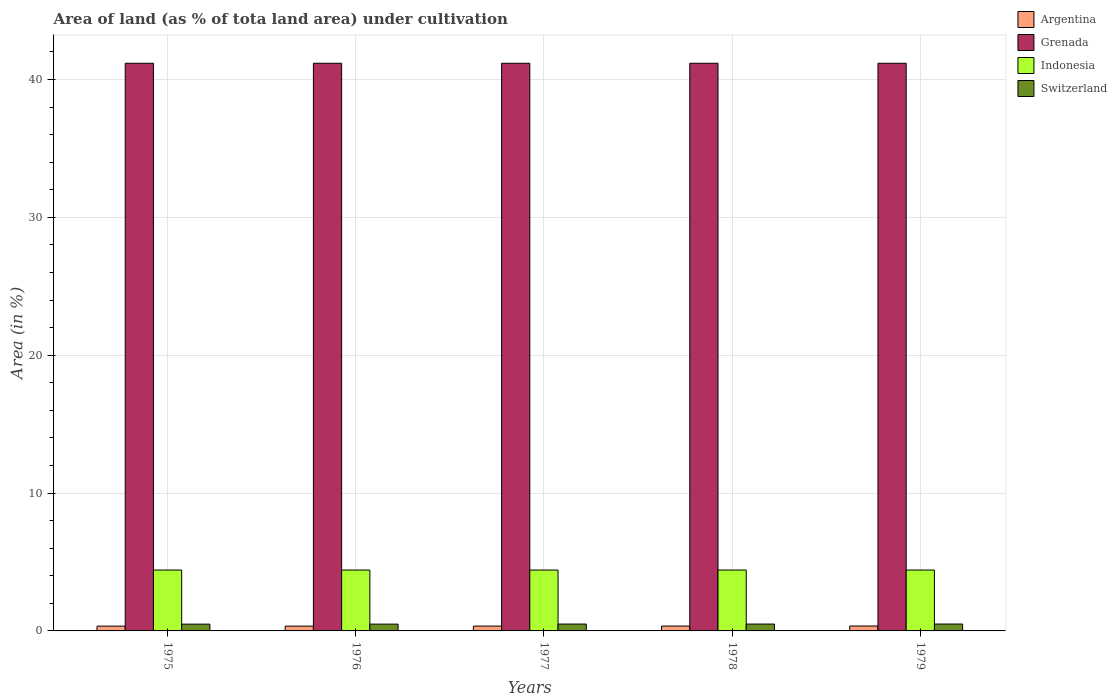What is the label of the 2nd group of bars from the left?
Provide a short and direct response. 1976. What is the percentage of land under cultivation in Switzerland in 1976?
Make the answer very short. 0.49. Across all years, what is the maximum percentage of land under cultivation in Grenada?
Offer a terse response. 41.18. Across all years, what is the minimum percentage of land under cultivation in Grenada?
Your answer should be very brief. 41.18. In which year was the percentage of land under cultivation in Indonesia maximum?
Offer a terse response. 1975. In which year was the percentage of land under cultivation in Grenada minimum?
Your answer should be very brief. 1975. What is the total percentage of land under cultivation in Argentina in the graph?
Offer a terse response. 1.76. What is the difference between the percentage of land under cultivation in Switzerland in 1976 and that in 1979?
Your answer should be compact. -0.01. What is the difference between the percentage of land under cultivation in Grenada in 1977 and the percentage of land under cultivation in Indonesia in 1979?
Ensure brevity in your answer.  36.76. What is the average percentage of land under cultivation in Switzerland per year?
Keep it short and to the point. 0.5. In the year 1977, what is the difference between the percentage of land under cultivation in Switzerland and percentage of land under cultivation in Grenada?
Make the answer very short. -40.68. What is the ratio of the percentage of land under cultivation in Argentina in 1975 to that in 1978?
Offer a very short reply. 0.98. Is the percentage of land under cultivation in Switzerland in 1977 less than that in 1979?
Provide a short and direct response. Yes. What is the difference between the highest and the second highest percentage of land under cultivation in Indonesia?
Provide a short and direct response. 0. In how many years, is the percentage of land under cultivation in Grenada greater than the average percentage of land under cultivation in Grenada taken over all years?
Offer a terse response. 0. Is the sum of the percentage of land under cultivation in Argentina in 1975 and 1978 greater than the maximum percentage of land under cultivation in Indonesia across all years?
Your response must be concise. No. Is it the case that in every year, the sum of the percentage of land under cultivation in Argentina and percentage of land under cultivation in Grenada is greater than the sum of percentage of land under cultivation in Indonesia and percentage of land under cultivation in Switzerland?
Your response must be concise. No. What does the 4th bar from the left in 1975 represents?
Your answer should be compact. Switzerland. How many bars are there?
Ensure brevity in your answer.  20. What is the difference between two consecutive major ticks on the Y-axis?
Your answer should be very brief. 10. Are the values on the major ticks of Y-axis written in scientific E-notation?
Keep it short and to the point. No. Where does the legend appear in the graph?
Make the answer very short. Top right. How many legend labels are there?
Offer a terse response. 4. How are the legend labels stacked?
Your answer should be compact. Vertical. What is the title of the graph?
Give a very brief answer. Area of land (as % of tota land area) under cultivation. Does "Dominican Republic" appear as one of the legend labels in the graph?
Ensure brevity in your answer.  No. What is the label or title of the X-axis?
Provide a short and direct response. Years. What is the label or title of the Y-axis?
Offer a terse response. Area (in %). What is the Area (in %) of Argentina in 1975?
Ensure brevity in your answer.  0.35. What is the Area (in %) of Grenada in 1975?
Keep it short and to the point. 41.18. What is the Area (in %) in Indonesia in 1975?
Your answer should be compact. 4.42. What is the Area (in %) of Switzerland in 1975?
Your response must be concise. 0.49. What is the Area (in %) of Argentina in 1976?
Provide a succinct answer. 0.35. What is the Area (in %) in Grenada in 1976?
Keep it short and to the point. 41.18. What is the Area (in %) in Indonesia in 1976?
Your answer should be very brief. 4.42. What is the Area (in %) of Switzerland in 1976?
Give a very brief answer. 0.49. What is the Area (in %) in Argentina in 1977?
Your answer should be compact. 0.35. What is the Area (in %) in Grenada in 1977?
Make the answer very short. 41.18. What is the Area (in %) of Indonesia in 1977?
Make the answer very short. 4.42. What is the Area (in %) of Switzerland in 1977?
Make the answer very short. 0.5. What is the Area (in %) of Argentina in 1978?
Provide a short and direct response. 0.35. What is the Area (in %) in Grenada in 1978?
Your response must be concise. 41.18. What is the Area (in %) in Indonesia in 1978?
Your answer should be very brief. 4.42. What is the Area (in %) in Switzerland in 1978?
Make the answer very short. 0.5. What is the Area (in %) of Argentina in 1979?
Your answer should be compact. 0.36. What is the Area (in %) of Grenada in 1979?
Provide a succinct answer. 41.18. What is the Area (in %) in Indonesia in 1979?
Ensure brevity in your answer.  4.42. What is the Area (in %) of Switzerland in 1979?
Provide a succinct answer. 0.5. Across all years, what is the maximum Area (in %) of Argentina?
Your answer should be very brief. 0.36. Across all years, what is the maximum Area (in %) of Grenada?
Make the answer very short. 41.18. Across all years, what is the maximum Area (in %) in Indonesia?
Your answer should be compact. 4.42. Across all years, what is the maximum Area (in %) in Switzerland?
Offer a very short reply. 0.5. Across all years, what is the minimum Area (in %) in Argentina?
Offer a very short reply. 0.35. Across all years, what is the minimum Area (in %) in Grenada?
Give a very brief answer. 41.18. Across all years, what is the minimum Area (in %) of Indonesia?
Provide a succinct answer. 4.42. Across all years, what is the minimum Area (in %) of Switzerland?
Provide a short and direct response. 0.49. What is the total Area (in %) in Argentina in the graph?
Keep it short and to the point. 1.76. What is the total Area (in %) of Grenada in the graph?
Your answer should be very brief. 205.88. What is the total Area (in %) in Indonesia in the graph?
Your answer should be very brief. 22.08. What is the total Area (in %) of Switzerland in the graph?
Make the answer very short. 2.48. What is the difference between the Area (in %) in Argentina in 1975 and that in 1976?
Your answer should be very brief. -0. What is the difference between the Area (in %) of Grenada in 1975 and that in 1976?
Offer a very short reply. 0. What is the difference between the Area (in %) of Indonesia in 1975 and that in 1976?
Provide a short and direct response. 0. What is the difference between the Area (in %) in Switzerland in 1975 and that in 1976?
Give a very brief answer. -0. What is the difference between the Area (in %) in Argentina in 1975 and that in 1977?
Make the answer very short. -0. What is the difference between the Area (in %) in Indonesia in 1975 and that in 1977?
Ensure brevity in your answer.  0. What is the difference between the Area (in %) of Switzerland in 1975 and that in 1977?
Your answer should be compact. -0.01. What is the difference between the Area (in %) in Argentina in 1975 and that in 1978?
Give a very brief answer. -0.01. What is the difference between the Area (in %) in Switzerland in 1975 and that in 1978?
Your answer should be compact. -0.01. What is the difference between the Area (in %) of Argentina in 1975 and that in 1979?
Make the answer very short. -0.01. What is the difference between the Area (in %) of Switzerland in 1975 and that in 1979?
Your response must be concise. -0.01. What is the difference between the Area (in %) of Argentina in 1976 and that in 1977?
Your response must be concise. -0. What is the difference between the Area (in %) of Indonesia in 1976 and that in 1977?
Keep it short and to the point. 0. What is the difference between the Area (in %) in Switzerland in 1976 and that in 1977?
Make the answer very short. -0.01. What is the difference between the Area (in %) of Argentina in 1976 and that in 1978?
Ensure brevity in your answer.  -0. What is the difference between the Area (in %) of Grenada in 1976 and that in 1978?
Provide a short and direct response. 0. What is the difference between the Area (in %) in Switzerland in 1976 and that in 1978?
Ensure brevity in your answer.  -0.01. What is the difference between the Area (in %) of Argentina in 1976 and that in 1979?
Offer a terse response. -0.01. What is the difference between the Area (in %) in Grenada in 1976 and that in 1979?
Your answer should be very brief. 0. What is the difference between the Area (in %) in Indonesia in 1976 and that in 1979?
Ensure brevity in your answer.  0. What is the difference between the Area (in %) in Switzerland in 1976 and that in 1979?
Make the answer very short. -0.01. What is the difference between the Area (in %) of Argentina in 1977 and that in 1978?
Offer a very short reply. -0. What is the difference between the Area (in %) in Switzerland in 1977 and that in 1978?
Make the answer very short. 0. What is the difference between the Area (in %) of Argentina in 1977 and that in 1979?
Keep it short and to the point. -0. What is the difference between the Area (in %) in Grenada in 1977 and that in 1979?
Give a very brief answer. 0. What is the difference between the Area (in %) in Switzerland in 1977 and that in 1979?
Provide a short and direct response. -0. What is the difference between the Area (in %) in Argentina in 1978 and that in 1979?
Offer a very short reply. -0. What is the difference between the Area (in %) in Indonesia in 1978 and that in 1979?
Your answer should be very brief. 0. What is the difference between the Area (in %) in Switzerland in 1978 and that in 1979?
Ensure brevity in your answer.  -0. What is the difference between the Area (in %) in Argentina in 1975 and the Area (in %) in Grenada in 1976?
Offer a very short reply. -40.83. What is the difference between the Area (in %) in Argentina in 1975 and the Area (in %) in Indonesia in 1976?
Your answer should be very brief. -4.07. What is the difference between the Area (in %) of Argentina in 1975 and the Area (in %) of Switzerland in 1976?
Provide a short and direct response. -0.15. What is the difference between the Area (in %) in Grenada in 1975 and the Area (in %) in Indonesia in 1976?
Give a very brief answer. 36.76. What is the difference between the Area (in %) in Grenada in 1975 and the Area (in %) in Switzerland in 1976?
Your answer should be very brief. 40.68. What is the difference between the Area (in %) of Indonesia in 1975 and the Area (in %) of Switzerland in 1976?
Give a very brief answer. 3.92. What is the difference between the Area (in %) of Argentina in 1975 and the Area (in %) of Grenada in 1977?
Your response must be concise. -40.83. What is the difference between the Area (in %) in Argentina in 1975 and the Area (in %) in Indonesia in 1977?
Your answer should be very brief. -4.07. What is the difference between the Area (in %) of Argentina in 1975 and the Area (in %) of Switzerland in 1977?
Provide a succinct answer. -0.15. What is the difference between the Area (in %) in Grenada in 1975 and the Area (in %) in Indonesia in 1977?
Your answer should be compact. 36.76. What is the difference between the Area (in %) in Grenada in 1975 and the Area (in %) in Switzerland in 1977?
Your answer should be very brief. 40.68. What is the difference between the Area (in %) of Indonesia in 1975 and the Area (in %) of Switzerland in 1977?
Keep it short and to the point. 3.92. What is the difference between the Area (in %) of Argentina in 1975 and the Area (in %) of Grenada in 1978?
Your answer should be very brief. -40.83. What is the difference between the Area (in %) in Argentina in 1975 and the Area (in %) in Indonesia in 1978?
Provide a short and direct response. -4.07. What is the difference between the Area (in %) in Argentina in 1975 and the Area (in %) in Switzerland in 1978?
Your answer should be very brief. -0.15. What is the difference between the Area (in %) in Grenada in 1975 and the Area (in %) in Indonesia in 1978?
Provide a short and direct response. 36.76. What is the difference between the Area (in %) of Grenada in 1975 and the Area (in %) of Switzerland in 1978?
Keep it short and to the point. 40.68. What is the difference between the Area (in %) of Indonesia in 1975 and the Area (in %) of Switzerland in 1978?
Give a very brief answer. 3.92. What is the difference between the Area (in %) in Argentina in 1975 and the Area (in %) in Grenada in 1979?
Provide a succinct answer. -40.83. What is the difference between the Area (in %) in Argentina in 1975 and the Area (in %) in Indonesia in 1979?
Keep it short and to the point. -4.07. What is the difference between the Area (in %) of Argentina in 1975 and the Area (in %) of Switzerland in 1979?
Give a very brief answer. -0.15. What is the difference between the Area (in %) in Grenada in 1975 and the Area (in %) in Indonesia in 1979?
Offer a terse response. 36.76. What is the difference between the Area (in %) in Grenada in 1975 and the Area (in %) in Switzerland in 1979?
Provide a short and direct response. 40.68. What is the difference between the Area (in %) of Indonesia in 1975 and the Area (in %) of Switzerland in 1979?
Offer a terse response. 3.92. What is the difference between the Area (in %) in Argentina in 1976 and the Area (in %) in Grenada in 1977?
Provide a succinct answer. -40.83. What is the difference between the Area (in %) in Argentina in 1976 and the Area (in %) in Indonesia in 1977?
Make the answer very short. -4.07. What is the difference between the Area (in %) of Argentina in 1976 and the Area (in %) of Switzerland in 1977?
Your response must be concise. -0.15. What is the difference between the Area (in %) in Grenada in 1976 and the Area (in %) in Indonesia in 1977?
Your response must be concise. 36.76. What is the difference between the Area (in %) in Grenada in 1976 and the Area (in %) in Switzerland in 1977?
Offer a terse response. 40.68. What is the difference between the Area (in %) of Indonesia in 1976 and the Area (in %) of Switzerland in 1977?
Your answer should be compact. 3.92. What is the difference between the Area (in %) in Argentina in 1976 and the Area (in %) in Grenada in 1978?
Provide a succinct answer. -40.83. What is the difference between the Area (in %) of Argentina in 1976 and the Area (in %) of Indonesia in 1978?
Provide a short and direct response. -4.07. What is the difference between the Area (in %) in Argentina in 1976 and the Area (in %) in Switzerland in 1978?
Ensure brevity in your answer.  -0.15. What is the difference between the Area (in %) in Grenada in 1976 and the Area (in %) in Indonesia in 1978?
Your response must be concise. 36.76. What is the difference between the Area (in %) of Grenada in 1976 and the Area (in %) of Switzerland in 1978?
Your answer should be compact. 40.68. What is the difference between the Area (in %) of Indonesia in 1976 and the Area (in %) of Switzerland in 1978?
Make the answer very short. 3.92. What is the difference between the Area (in %) of Argentina in 1976 and the Area (in %) of Grenada in 1979?
Give a very brief answer. -40.83. What is the difference between the Area (in %) of Argentina in 1976 and the Area (in %) of Indonesia in 1979?
Make the answer very short. -4.07. What is the difference between the Area (in %) of Argentina in 1976 and the Area (in %) of Switzerland in 1979?
Offer a terse response. -0.15. What is the difference between the Area (in %) of Grenada in 1976 and the Area (in %) of Indonesia in 1979?
Your answer should be compact. 36.76. What is the difference between the Area (in %) of Grenada in 1976 and the Area (in %) of Switzerland in 1979?
Your answer should be very brief. 40.68. What is the difference between the Area (in %) of Indonesia in 1976 and the Area (in %) of Switzerland in 1979?
Ensure brevity in your answer.  3.92. What is the difference between the Area (in %) in Argentina in 1977 and the Area (in %) in Grenada in 1978?
Your answer should be compact. -40.82. What is the difference between the Area (in %) of Argentina in 1977 and the Area (in %) of Indonesia in 1978?
Provide a short and direct response. -4.06. What is the difference between the Area (in %) in Argentina in 1977 and the Area (in %) in Switzerland in 1978?
Your answer should be compact. -0.15. What is the difference between the Area (in %) in Grenada in 1977 and the Area (in %) in Indonesia in 1978?
Provide a short and direct response. 36.76. What is the difference between the Area (in %) in Grenada in 1977 and the Area (in %) in Switzerland in 1978?
Offer a terse response. 40.68. What is the difference between the Area (in %) in Indonesia in 1977 and the Area (in %) in Switzerland in 1978?
Make the answer very short. 3.92. What is the difference between the Area (in %) in Argentina in 1977 and the Area (in %) in Grenada in 1979?
Offer a very short reply. -40.82. What is the difference between the Area (in %) in Argentina in 1977 and the Area (in %) in Indonesia in 1979?
Ensure brevity in your answer.  -4.06. What is the difference between the Area (in %) in Argentina in 1977 and the Area (in %) in Switzerland in 1979?
Make the answer very short. -0.15. What is the difference between the Area (in %) of Grenada in 1977 and the Area (in %) of Indonesia in 1979?
Keep it short and to the point. 36.76. What is the difference between the Area (in %) of Grenada in 1977 and the Area (in %) of Switzerland in 1979?
Provide a succinct answer. 40.68. What is the difference between the Area (in %) of Indonesia in 1977 and the Area (in %) of Switzerland in 1979?
Your response must be concise. 3.92. What is the difference between the Area (in %) of Argentina in 1978 and the Area (in %) of Grenada in 1979?
Provide a succinct answer. -40.82. What is the difference between the Area (in %) of Argentina in 1978 and the Area (in %) of Indonesia in 1979?
Offer a very short reply. -4.06. What is the difference between the Area (in %) in Argentina in 1978 and the Area (in %) in Switzerland in 1979?
Provide a short and direct response. -0.15. What is the difference between the Area (in %) of Grenada in 1978 and the Area (in %) of Indonesia in 1979?
Your answer should be compact. 36.76. What is the difference between the Area (in %) in Grenada in 1978 and the Area (in %) in Switzerland in 1979?
Ensure brevity in your answer.  40.68. What is the difference between the Area (in %) of Indonesia in 1978 and the Area (in %) of Switzerland in 1979?
Your answer should be compact. 3.92. What is the average Area (in %) of Argentina per year?
Make the answer very short. 0.35. What is the average Area (in %) of Grenada per year?
Ensure brevity in your answer.  41.18. What is the average Area (in %) of Indonesia per year?
Give a very brief answer. 4.42. What is the average Area (in %) in Switzerland per year?
Offer a very short reply. 0.5. In the year 1975, what is the difference between the Area (in %) in Argentina and Area (in %) in Grenada?
Your response must be concise. -40.83. In the year 1975, what is the difference between the Area (in %) of Argentina and Area (in %) of Indonesia?
Ensure brevity in your answer.  -4.07. In the year 1975, what is the difference between the Area (in %) of Argentina and Area (in %) of Switzerland?
Your answer should be very brief. -0.14. In the year 1975, what is the difference between the Area (in %) in Grenada and Area (in %) in Indonesia?
Keep it short and to the point. 36.76. In the year 1975, what is the difference between the Area (in %) of Grenada and Area (in %) of Switzerland?
Give a very brief answer. 40.69. In the year 1975, what is the difference between the Area (in %) of Indonesia and Area (in %) of Switzerland?
Offer a terse response. 3.93. In the year 1976, what is the difference between the Area (in %) in Argentina and Area (in %) in Grenada?
Provide a short and direct response. -40.83. In the year 1976, what is the difference between the Area (in %) in Argentina and Area (in %) in Indonesia?
Offer a very short reply. -4.07. In the year 1976, what is the difference between the Area (in %) of Argentina and Area (in %) of Switzerland?
Provide a succinct answer. -0.14. In the year 1976, what is the difference between the Area (in %) of Grenada and Area (in %) of Indonesia?
Provide a succinct answer. 36.76. In the year 1976, what is the difference between the Area (in %) of Grenada and Area (in %) of Switzerland?
Your answer should be very brief. 40.68. In the year 1976, what is the difference between the Area (in %) in Indonesia and Area (in %) in Switzerland?
Offer a terse response. 3.92. In the year 1977, what is the difference between the Area (in %) in Argentina and Area (in %) in Grenada?
Make the answer very short. -40.82. In the year 1977, what is the difference between the Area (in %) of Argentina and Area (in %) of Indonesia?
Offer a terse response. -4.06. In the year 1977, what is the difference between the Area (in %) in Argentina and Area (in %) in Switzerland?
Your response must be concise. -0.15. In the year 1977, what is the difference between the Area (in %) of Grenada and Area (in %) of Indonesia?
Your answer should be compact. 36.76. In the year 1977, what is the difference between the Area (in %) in Grenada and Area (in %) in Switzerland?
Your answer should be very brief. 40.68. In the year 1977, what is the difference between the Area (in %) of Indonesia and Area (in %) of Switzerland?
Provide a short and direct response. 3.92. In the year 1978, what is the difference between the Area (in %) of Argentina and Area (in %) of Grenada?
Provide a succinct answer. -40.82. In the year 1978, what is the difference between the Area (in %) in Argentina and Area (in %) in Indonesia?
Keep it short and to the point. -4.06. In the year 1978, what is the difference between the Area (in %) of Argentina and Area (in %) of Switzerland?
Provide a succinct answer. -0.14. In the year 1978, what is the difference between the Area (in %) of Grenada and Area (in %) of Indonesia?
Give a very brief answer. 36.76. In the year 1978, what is the difference between the Area (in %) of Grenada and Area (in %) of Switzerland?
Provide a short and direct response. 40.68. In the year 1978, what is the difference between the Area (in %) in Indonesia and Area (in %) in Switzerland?
Your answer should be compact. 3.92. In the year 1979, what is the difference between the Area (in %) in Argentina and Area (in %) in Grenada?
Offer a terse response. -40.82. In the year 1979, what is the difference between the Area (in %) of Argentina and Area (in %) of Indonesia?
Ensure brevity in your answer.  -4.06. In the year 1979, what is the difference between the Area (in %) of Argentina and Area (in %) of Switzerland?
Your answer should be very brief. -0.14. In the year 1979, what is the difference between the Area (in %) in Grenada and Area (in %) in Indonesia?
Your response must be concise. 36.76. In the year 1979, what is the difference between the Area (in %) of Grenada and Area (in %) of Switzerland?
Offer a terse response. 40.68. In the year 1979, what is the difference between the Area (in %) in Indonesia and Area (in %) in Switzerland?
Your answer should be very brief. 3.92. What is the ratio of the Area (in %) of Argentina in 1975 to that in 1976?
Offer a very short reply. 0.99. What is the ratio of the Area (in %) in Indonesia in 1975 to that in 1976?
Provide a short and direct response. 1. What is the ratio of the Area (in %) of Switzerland in 1975 to that in 1976?
Your answer should be very brief. 0.99. What is the ratio of the Area (in %) of Grenada in 1975 to that in 1977?
Make the answer very short. 1. What is the ratio of the Area (in %) in Argentina in 1975 to that in 1978?
Make the answer very short. 0.98. What is the ratio of the Area (in %) in Argentina in 1975 to that in 1979?
Make the answer very short. 0.98. What is the ratio of the Area (in %) of Grenada in 1975 to that in 1979?
Ensure brevity in your answer.  1. What is the ratio of the Area (in %) in Indonesia in 1975 to that in 1979?
Your answer should be compact. 1. What is the ratio of the Area (in %) of Switzerland in 1975 to that in 1979?
Your answer should be compact. 0.98. What is the ratio of the Area (in %) of Indonesia in 1976 to that in 1977?
Keep it short and to the point. 1. What is the ratio of the Area (in %) in Argentina in 1976 to that in 1978?
Ensure brevity in your answer.  0.99. What is the ratio of the Area (in %) in Switzerland in 1976 to that in 1978?
Give a very brief answer. 0.99. What is the ratio of the Area (in %) in Argentina in 1976 to that in 1979?
Your response must be concise. 0.98. What is the ratio of the Area (in %) of Indonesia in 1976 to that in 1979?
Ensure brevity in your answer.  1. What is the ratio of the Area (in %) in Switzerland in 1976 to that in 1979?
Offer a terse response. 0.98. What is the ratio of the Area (in %) in Grenada in 1977 to that in 1978?
Make the answer very short. 1. What is the ratio of the Area (in %) of Argentina in 1977 to that in 1979?
Make the answer very short. 0.99. What is the ratio of the Area (in %) in Grenada in 1977 to that in 1979?
Keep it short and to the point. 1. What is the ratio of the Area (in %) of Indonesia in 1977 to that in 1979?
Your response must be concise. 1. What is the ratio of the Area (in %) in Argentina in 1978 to that in 1979?
Your answer should be very brief. 0.99. What is the ratio of the Area (in %) of Grenada in 1978 to that in 1979?
Provide a short and direct response. 1. What is the ratio of the Area (in %) of Switzerland in 1978 to that in 1979?
Offer a very short reply. 0.99. What is the difference between the highest and the second highest Area (in %) of Argentina?
Your answer should be compact. 0. What is the difference between the highest and the second highest Area (in %) of Grenada?
Provide a succinct answer. 0. What is the difference between the highest and the second highest Area (in %) of Indonesia?
Your response must be concise. 0. What is the difference between the highest and the second highest Area (in %) in Switzerland?
Your response must be concise. 0. What is the difference between the highest and the lowest Area (in %) of Argentina?
Provide a succinct answer. 0.01. What is the difference between the highest and the lowest Area (in %) in Grenada?
Ensure brevity in your answer.  0. What is the difference between the highest and the lowest Area (in %) in Indonesia?
Make the answer very short. 0. What is the difference between the highest and the lowest Area (in %) in Switzerland?
Offer a terse response. 0.01. 